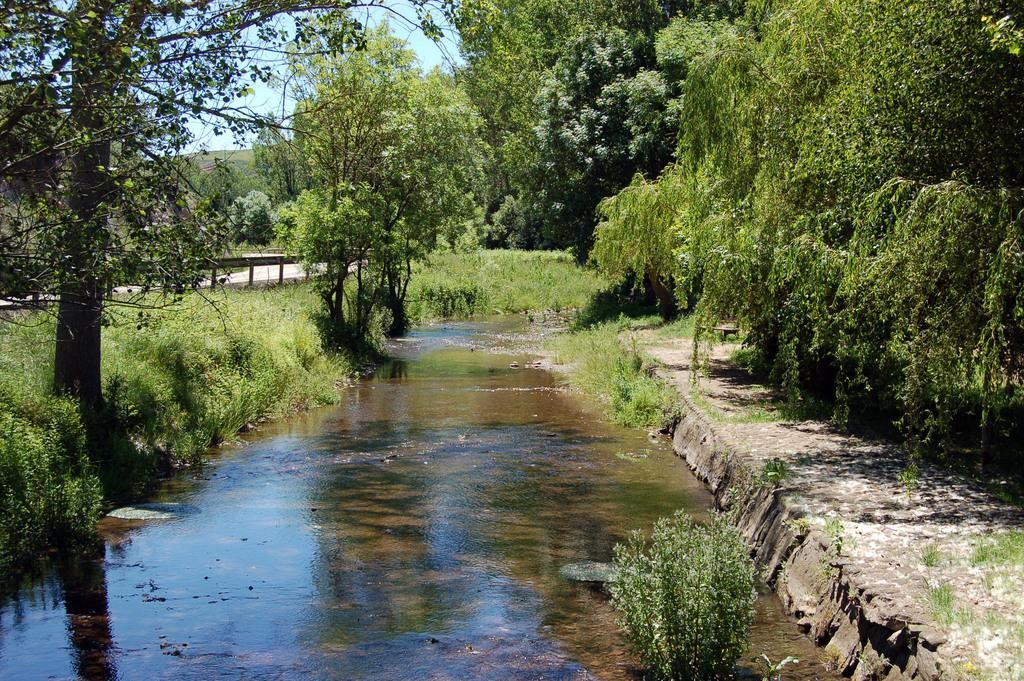What type of living organisms can be seen in the image? Plants and trees are visible in the image. What natural element is visible in the image? Water is visible in the image. What is visible in the background of the image? The sky is visible in the background of the image. Where is the beggar located in the image? There is no beggar present in the image. What type of food is the chicken eating in the image? There is no chicken present in the image. 